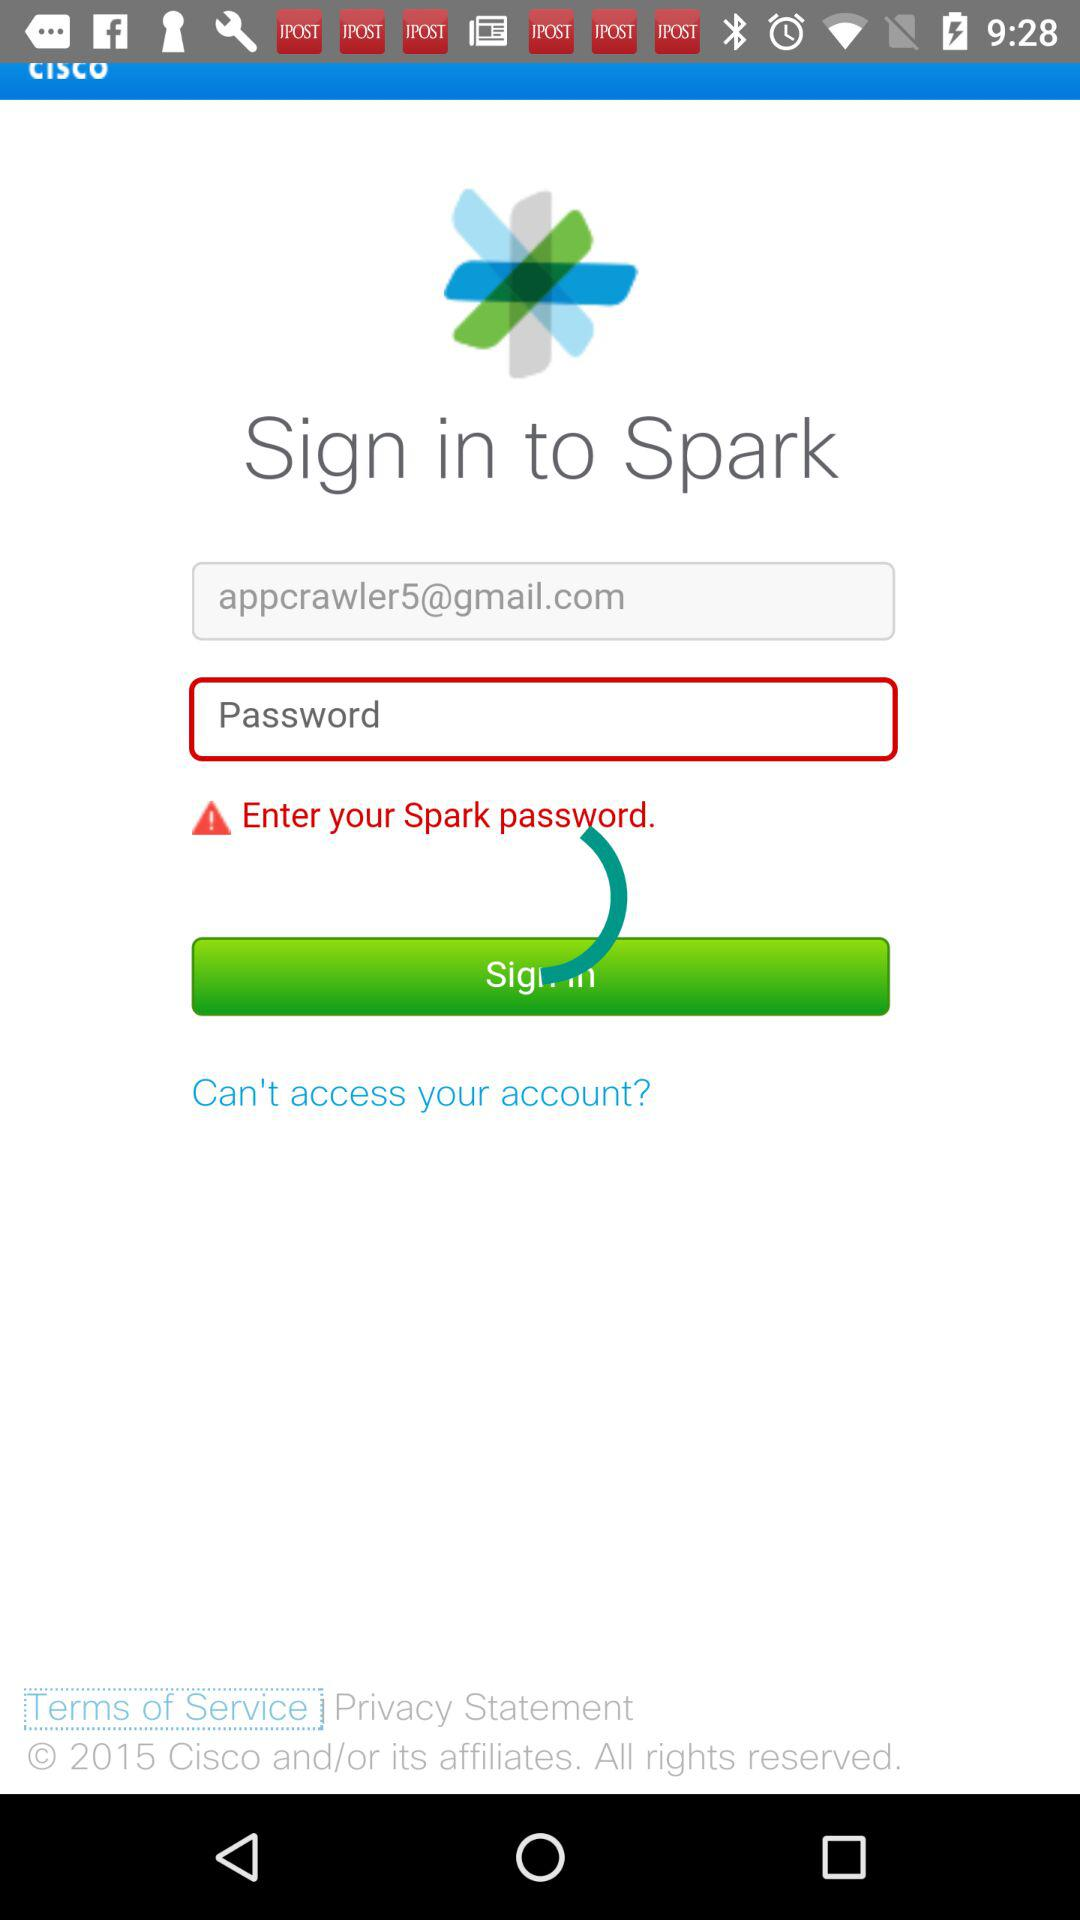What is the email address? The email address is appcrawler5@gmail.com. 